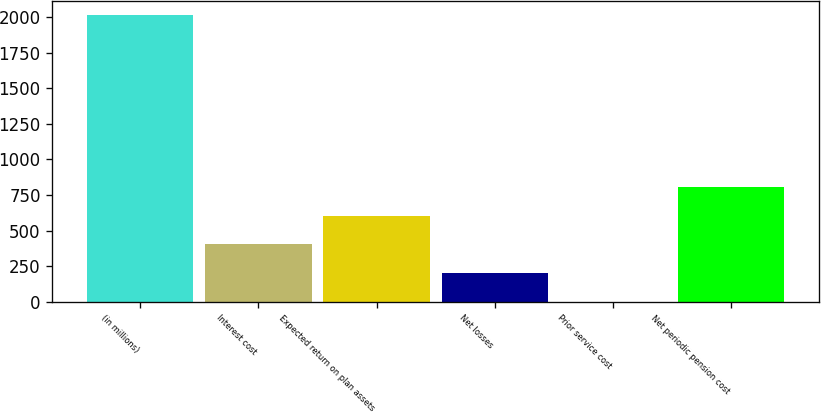<chart> <loc_0><loc_0><loc_500><loc_500><bar_chart><fcel>(in millions)<fcel>Interest cost<fcel>Expected return on plan assets<fcel>Net losses<fcel>Prior service cost<fcel>Net periodic pension cost<nl><fcel>2013<fcel>403.4<fcel>604.6<fcel>202.2<fcel>1<fcel>805.8<nl></chart> 